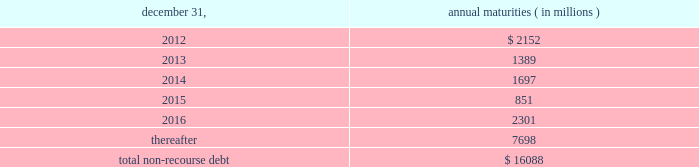The aes corporation notes to consolidated financial statements 2014 ( continued ) december 31 , 2011 , 2010 , and 2009 ( 1 ) weighted average interest rate at december 31 , 2011 .
( 2 ) the company has interest rate swaps and interest rate option agreements in an aggregate notional principal amount of approximately $ 3.6 billion on non-recourse debt outstanding at december 31 , 2011 .
The swap agreements economically change the variable interest rates on the portion of the debt covered by the notional amounts to fixed rates ranging from approximately 1.44% ( 1.44 % ) to 6.98% ( 6.98 % ) .
The option agreements fix interest rates within a range from 1.00% ( 1.00 % ) to 7.00% ( 7.00 % ) .
The agreements expire at various dates from 2016 through 2028 .
( 3 ) multilateral loans include loans funded and guaranteed by bilaterals , multilaterals , development banks and other similar institutions .
( 4 ) non-recourse debt of $ 704 million and $ 945 million as of december 31 , 2011 and 2010 , respectively , was excluded from non-recourse debt and included in current and long-term liabilities of held for sale and discontinued businesses in the accompanying consolidated balance sheets .
Non-recourse debt as of december 31 , 2011 is scheduled to reach maturity as set forth in the table below : december 31 , annual maturities ( in millions ) .
As of december 31 , 2011 , aes subsidiaries with facilities under construction had a total of approximately $ 1.4 billion of committed but unused credit facilities available to fund construction and other related costs .
Excluding these facilities under construction , aes subsidiaries had approximately $ 1.2 billion in a number of available but unused committed revolving credit lines to support their working capital , debt service reserves and other business needs .
These credit lines can be used in one or more of the following ways : solely for borrowings ; solely for letters of credit ; or a combination of these uses .
The weighted average interest rate on borrowings from these facilities was 14.75% ( 14.75 % ) at december 31 , 2011 .
On october 3 , 2011 , dolphin subsidiary ii , inc .
( 201cdolphin ii 201d ) , a newly formed , wholly-owned special purpose indirect subsidiary of aes , entered into an indenture ( the 201cindenture 201d ) with wells fargo bank , n.a .
( the 201ctrustee 201d ) as part of its issuance of $ 450 million aggregate principal amount of 6.50% ( 6.50 % ) senior notes due 2016 ( the 201c2016 notes 201d ) and $ 800 million aggregate principal amount of 7.25% ( 7.25 % ) senior notes due 2021 ( the 201c7.25% ( 201c7.25 % ) 2021 notes 201d , together with the 2016 notes , the 201cnotes 201d ) to finance the acquisition ( the 201cacquisition 201d ) of dpl .
Upon closing of the acquisition on november 28 , 2011 , dolphin ii was merged into dpl with dpl being the surviving entity and obligor .
The 2016 notes and the 7.25% ( 7.25 % ) 2021 notes are included under 201cnotes and bonds 201d in the non-recourse detail table above .
See note 23 2014acquisitions and dispositions for further information .
Interest on the 2016 notes and the 7.25% ( 7.25 % ) 2021 notes accrues at a rate of 6.50% ( 6.50 % ) and 7.25% ( 7.25 % ) per year , respectively , and is payable on april 15 and october 15 of each year , beginning april 15 , 2012 .
Prior to september 15 , 2016 with respect to the 2016 notes and july 15 , 2021 with respect to the 7.25% ( 7.25 % ) 2021 notes , dpl may redeem some or all of the 2016 notes or 7.25% ( 7.25 % ) 2021 notes at par , plus a 201cmake-whole 201d amount set forth in .
What percentage of total non-recourse debt as of december 31 , 2011 is due in 2015? 
Computations: (851 / 16088)
Answer: 0.0529. 